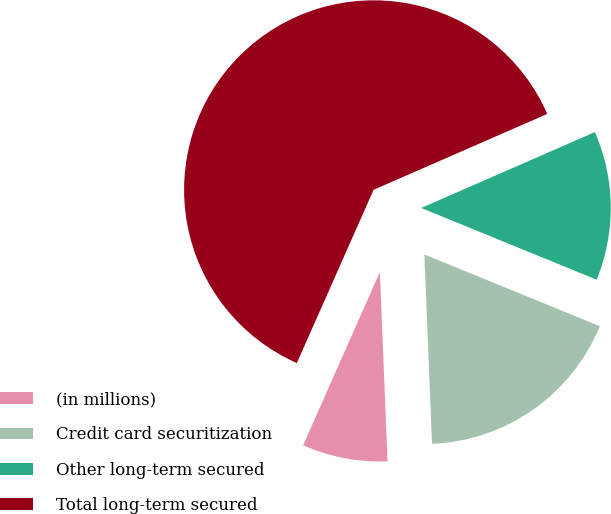<chart> <loc_0><loc_0><loc_500><loc_500><pie_chart><fcel>(in millions)<fcel>Credit card securitization<fcel>Other long-term secured<fcel>Total long-term secured<nl><fcel>7.28%<fcel>18.18%<fcel>12.73%<fcel>61.8%<nl></chart> 